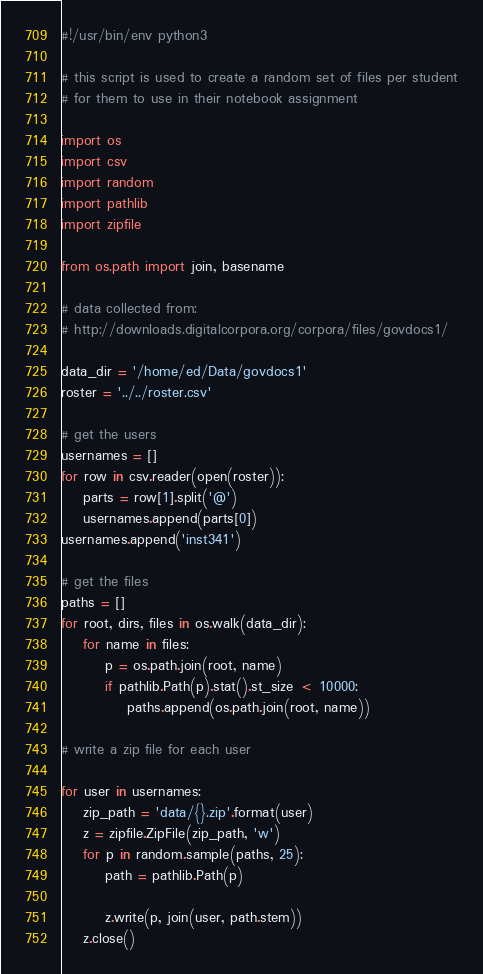<code> <loc_0><loc_0><loc_500><loc_500><_Python_>#!/usr/bin/env python3 

# this script is used to create a random set of files per student
# for them to use in their notebook assignment

import os
import csv
import random
import pathlib
import zipfile

from os.path import join, basename

# data collected from:
# http://downloads.digitalcorpora.org/corpora/files/govdocs1/

data_dir = '/home/ed/Data/govdocs1'
roster = '../../roster.csv'

# get the users
usernames = []
for row in csv.reader(open(roster)):
    parts = row[1].split('@')
    usernames.append(parts[0])
usernames.append('inst341')

# get the files
paths = []
for root, dirs, files in os.walk(data_dir):
    for name in files:
        p = os.path.join(root, name)
        if pathlib.Path(p).stat().st_size < 10000:
            paths.append(os.path.join(root, name))

# write a zip file for each user

for user in usernames:
    zip_path = 'data/{}.zip'.format(user)
    z = zipfile.ZipFile(zip_path, 'w')
    for p in random.sample(paths, 25):
        path = pathlib.Path(p)
        
        z.write(p, join(user, path.stem))
    z.close()
</code> 